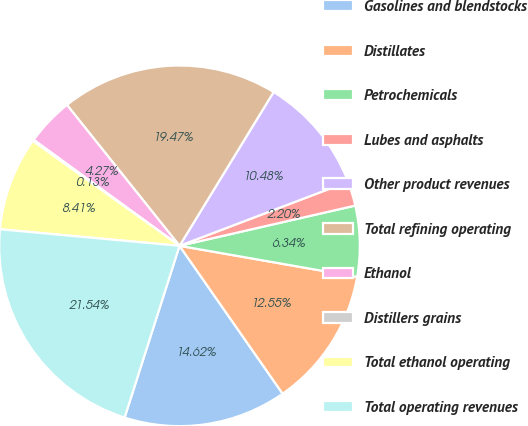Convert chart to OTSL. <chart><loc_0><loc_0><loc_500><loc_500><pie_chart><fcel>Gasolines and blendstocks<fcel>Distillates<fcel>Petrochemicals<fcel>Lubes and asphalts<fcel>Other product revenues<fcel>Total refining operating<fcel>Ethanol<fcel>Distillers grains<fcel>Total ethanol operating<fcel>Total operating revenues<nl><fcel>14.62%<fcel>12.55%<fcel>6.34%<fcel>2.2%<fcel>10.48%<fcel>19.47%<fcel>4.27%<fcel>0.13%<fcel>8.41%<fcel>21.54%<nl></chart> 